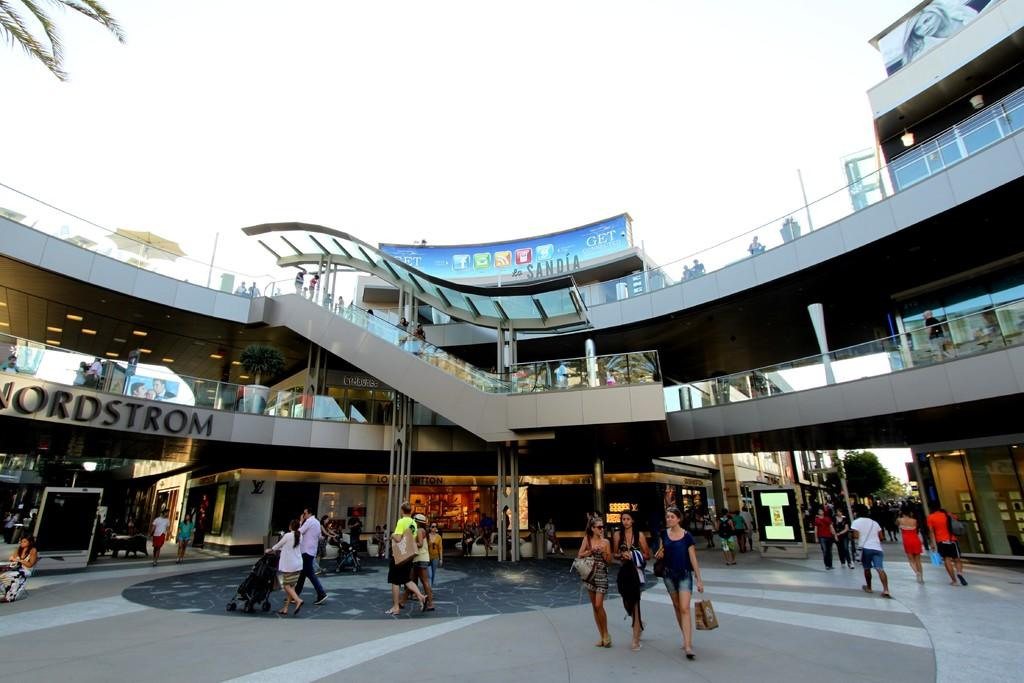What are the people in the image doing? The people in the image are walking. What can be seen in the background of the image? There is a building and stores visible in the background of the image. What is visible at the top of the image? The sky is visible at the top of the image. What type of vegetation is present in the image? Trees are present in the image. What mode of transportation can be seen in the image? There is a trolley in the image. Can you tell me how many books are on the shelves in the image? There are no shelves or books visible in the image. What type of hose is being used by the people walking in the image? There is no hose present in the image; the people are simply walking. 